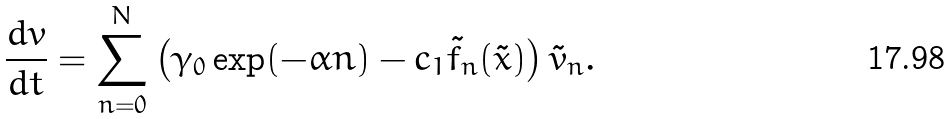Convert formula to latex. <formula><loc_0><loc_0><loc_500><loc_500>\frac { d v } { d t } = \sum _ { n = 0 } ^ { N } \left ( \gamma _ { 0 } \exp ( - \alpha n ) - c _ { 1 } \tilde { f } _ { n } ( \tilde { x } ) \right ) \tilde { v } _ { n } .</formula> 